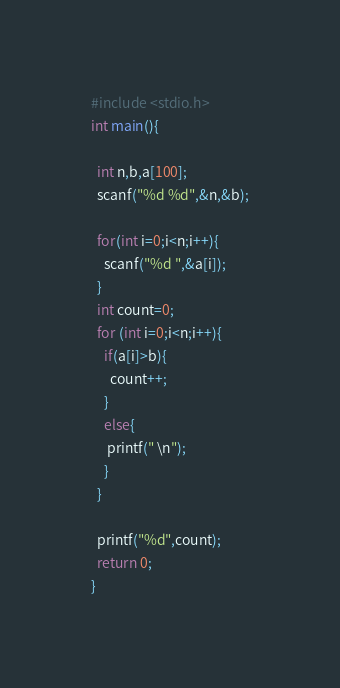<code> <loc_0><loc_0><loc_500><loc_500><_C_>#include <stdio.h>
int main(){
 
  int n,b,a[100];
  scanf("%d %d",&n,&b);

  for(int i=0;i<n;i++){
    scanf("%d ",&a[i]);
  }
  int count=0;
  for (int i=0;i<n;i++){
    if(a[i]>b){
      count++;
    }
    else{
     printf(" \n");
    }
  }

  printf("%d",count);
  return 0;
}</code> 